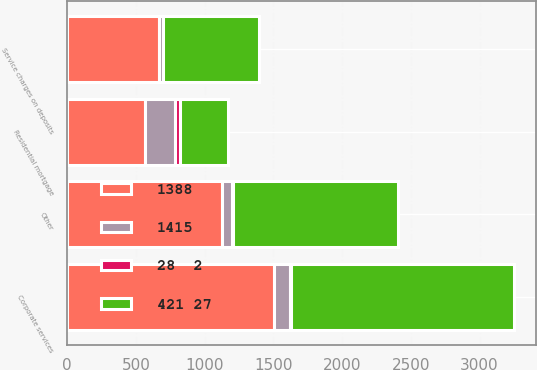<chart> <loc_0><loc_0><loc_500><loc_500><stacked_bar_chart><ecel><fcel>Corporate services<fcel>Residential mortgage<fcel>Service charges on deposits<fcel>Other<nl><fcel>421 27<fcel>1621<fcel>350<fcel>695<fcel>1198<nl><fcel>1388<fcel>1504<fcel>567<fcel>667<fcel>1124<nl><fcel>1415<fcel>117<fcel>217<fcel>28<fcel>74<nl><fcel>28  2<fcel>8<fcel>38<fcel>4<fcel>7<nl></chart> 